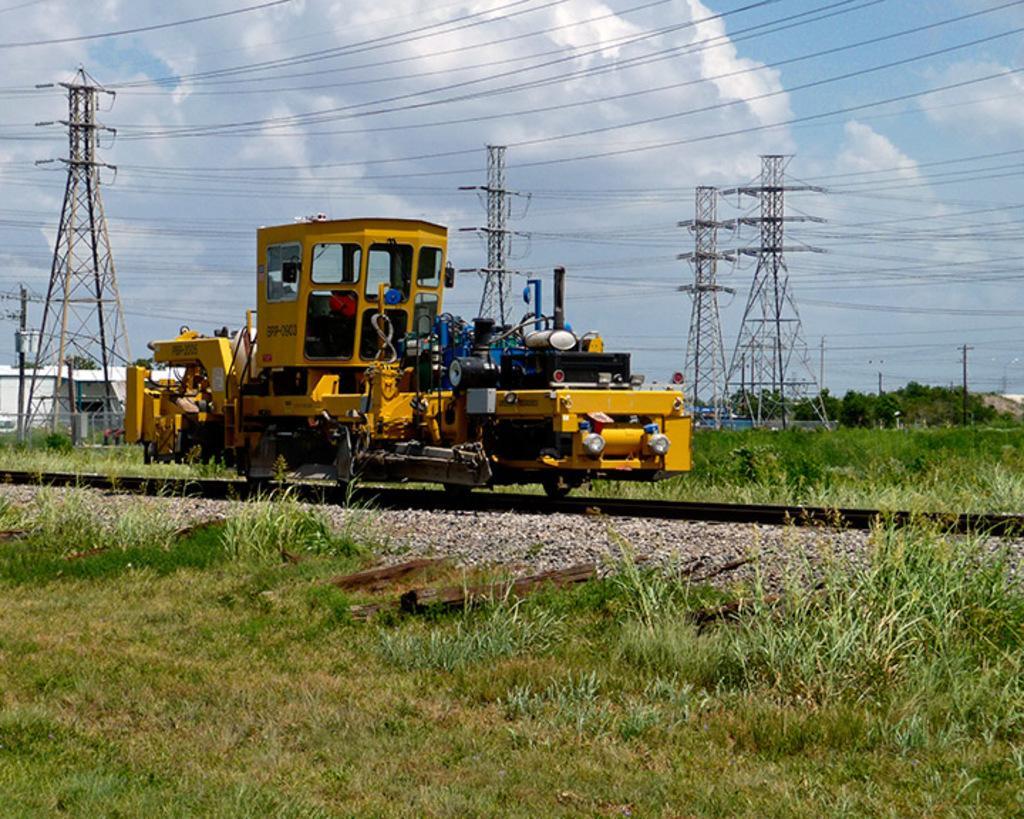In one or two sentences, can you explain what this image depicts? In the picture I can see vehicle on the railway track. In the background I can see the grass, wires attached to towers, buildings, trees, poles, the sky and some other objects on the ground. 